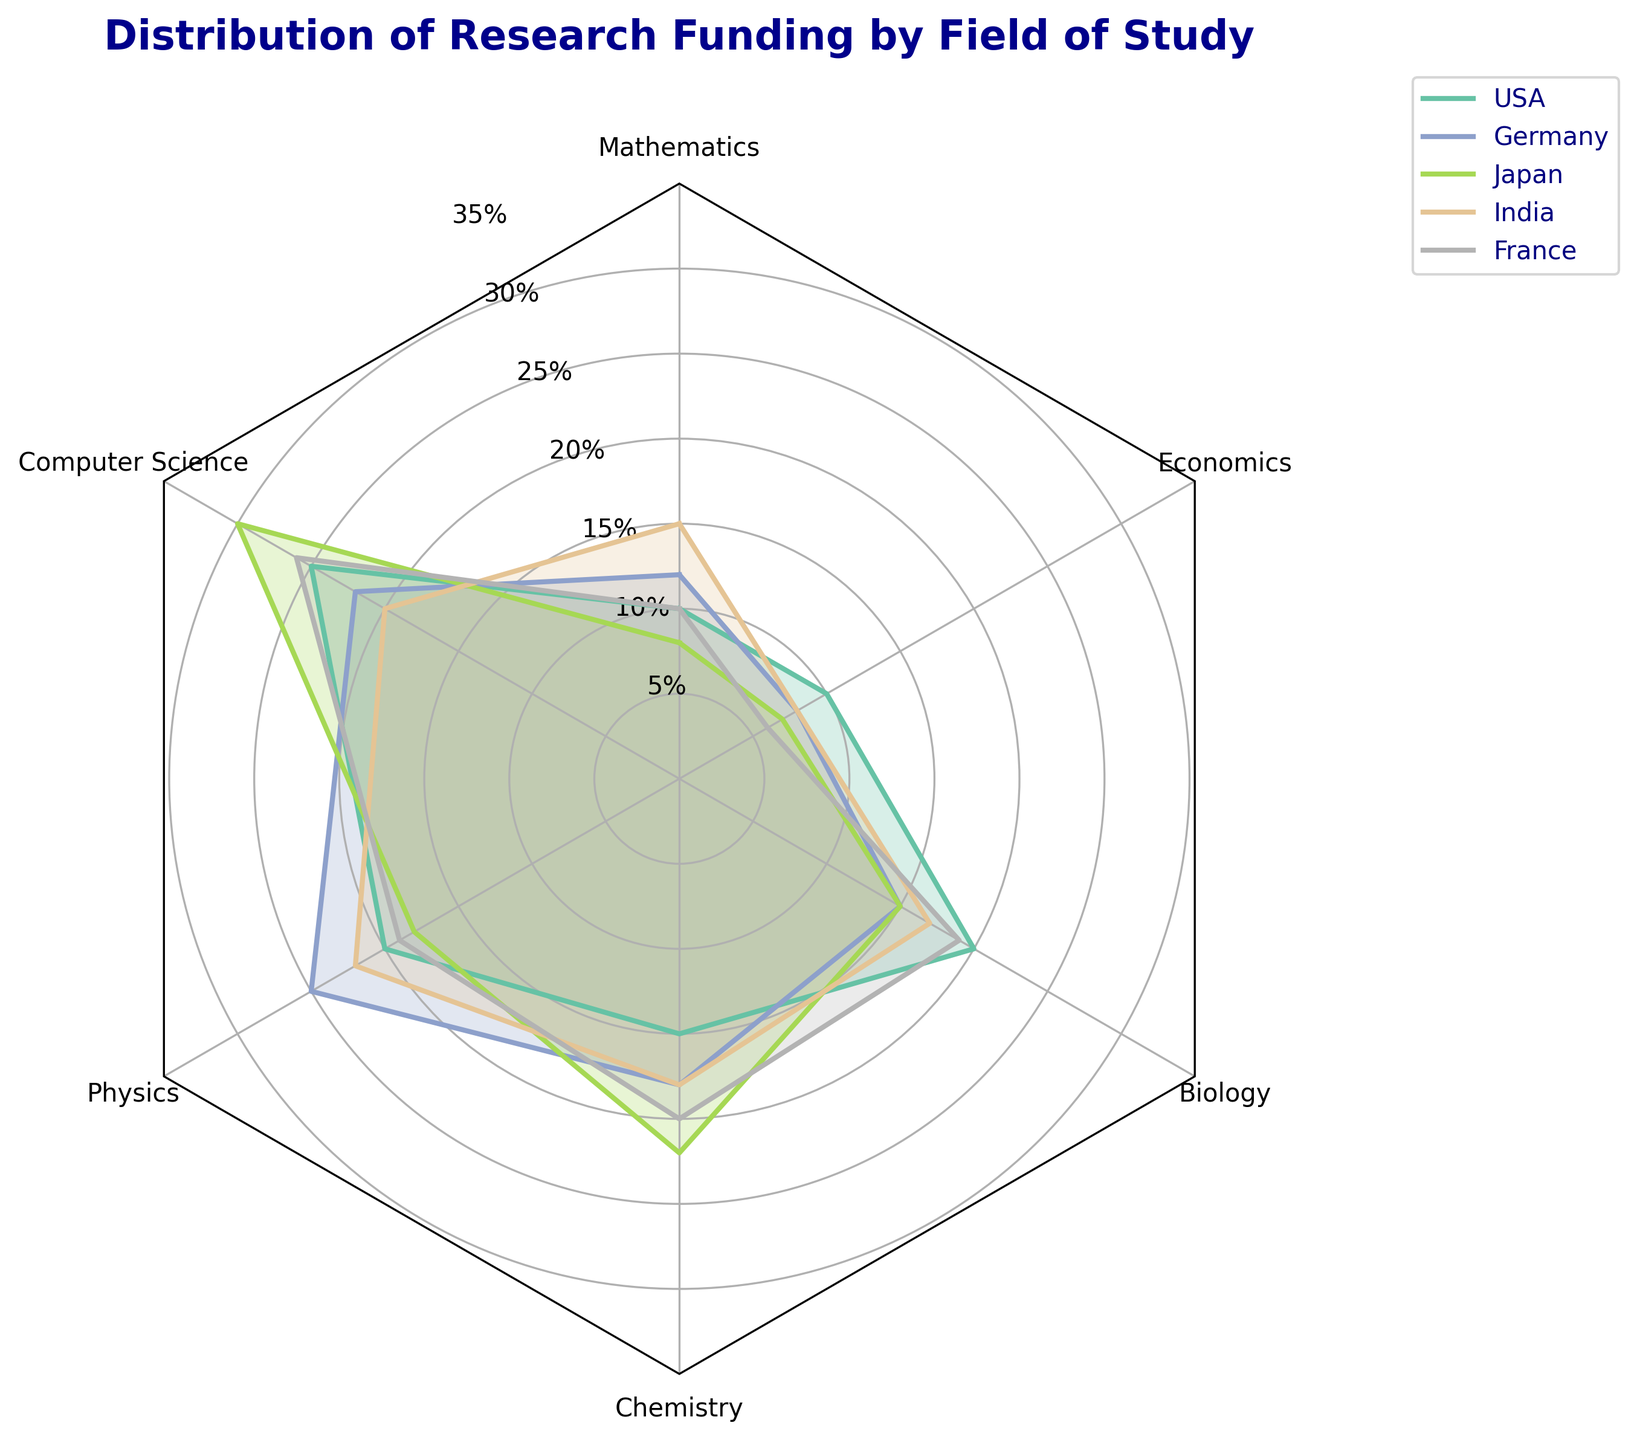What is the field that receives the highest percentage of funding in Japan? To find the field with the highest percentage in Japan, observe the radar plot for Japan's data points and check which field has the highest value. This is evident from the extended line segment representing Japan under computer science.
Answer: Computer Science Which country has the most balanced distribution of funding across all fields? A balanced distribution means each field receives a similar amount of funding, resulting in a more circular shape in the radar chart. Germany's data points form a relatively even distribution compared to other countries, reflected by a more regular polygon shape.
Answer: Germany What is the maximum percentage of total funding allocated to any field in the USA? To find the maximum funding percentage in the USA, look at the data points representing the USA and identify the highest value. It's clear from the chart that the longest line segment for the USA is 25% under Computer Science.
Answer: 25% Between Germany and France, which country spends more on Economics research? Compare Germany's and France's data points specifically in the Economics section. Observing the chart tells us that Germany allocates 8% while France allocates 6% to Economics, indicating Germany spends more.
Answer: Germany Among all the countries, which one allocates the highest percentage of research funding to Mathematics? Check the Mathematics sections for all countries, looking for the highest percentage. India shows the longest line in the Mathematics section at 15%.
Answer: India How does the funding allocation in Biology compare between the USA and India? Look at the data points for the USA and India in the Biology section and compare their lengths. Both the USA and India show the same funding allocation at 20%.
Answer: Equal What is the total funding percentage for Chemistry and Physics combined in Germany? To find this combined total, locate and sum the percentages for Chemistry and Physics in Germany. Chemistry receives 18% and Physics 25%, making the total 18% + 25% = 43%.
Answer: 43% Which field does India invest in more compared to Japan? Compare the data points of India and Japan for each field. Notably, India allocates more funding to Mathematics with 15% compared to Japan's 8%.
Answer: Mathematics Which country spends the least on Economics research? Look at the Economics section and identify the shortest line segments. France allocates the least, at 6%.
Answer: France 